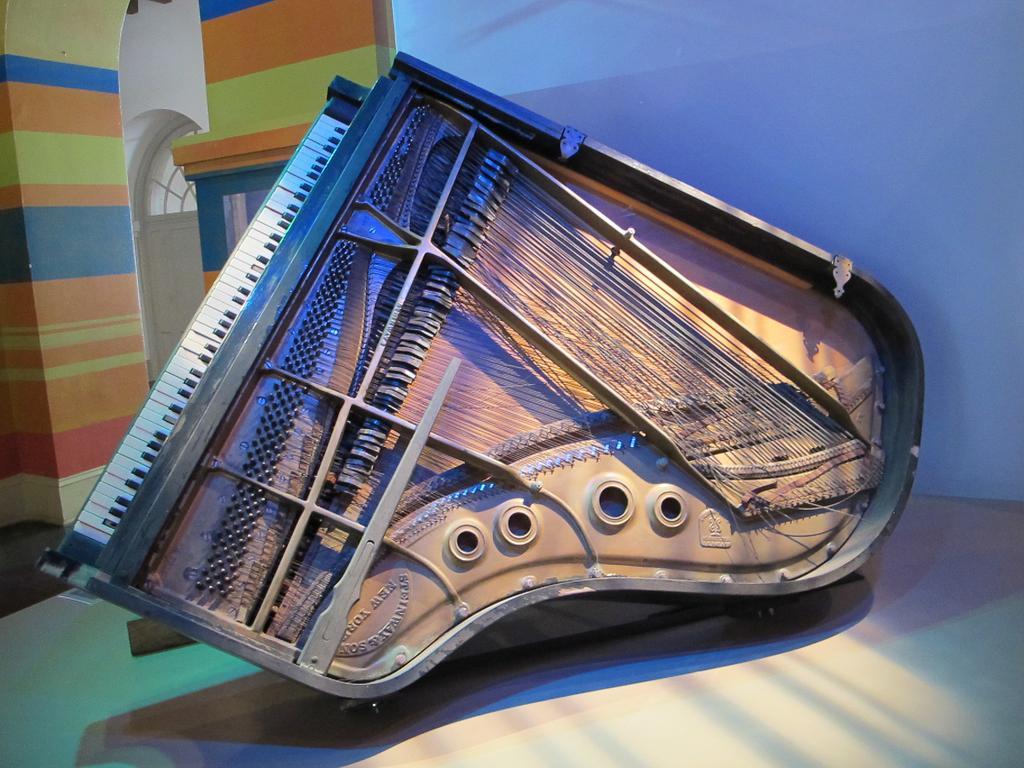Please provide a concise description of this image. There is a piano which has some painting on it is placed on a table and the background wall is different in color. 